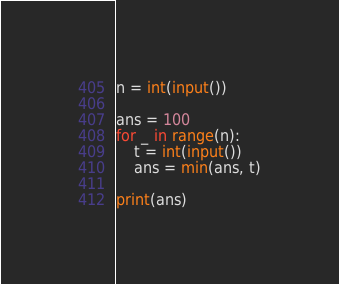<code> <loc_0><loc_0><loc_500><loc_500><_Python_>n = int(input())

ans = 100
for _ in range(n):
    t = int(input())
    ans = min(ans, t)

print(ans)
</code> 